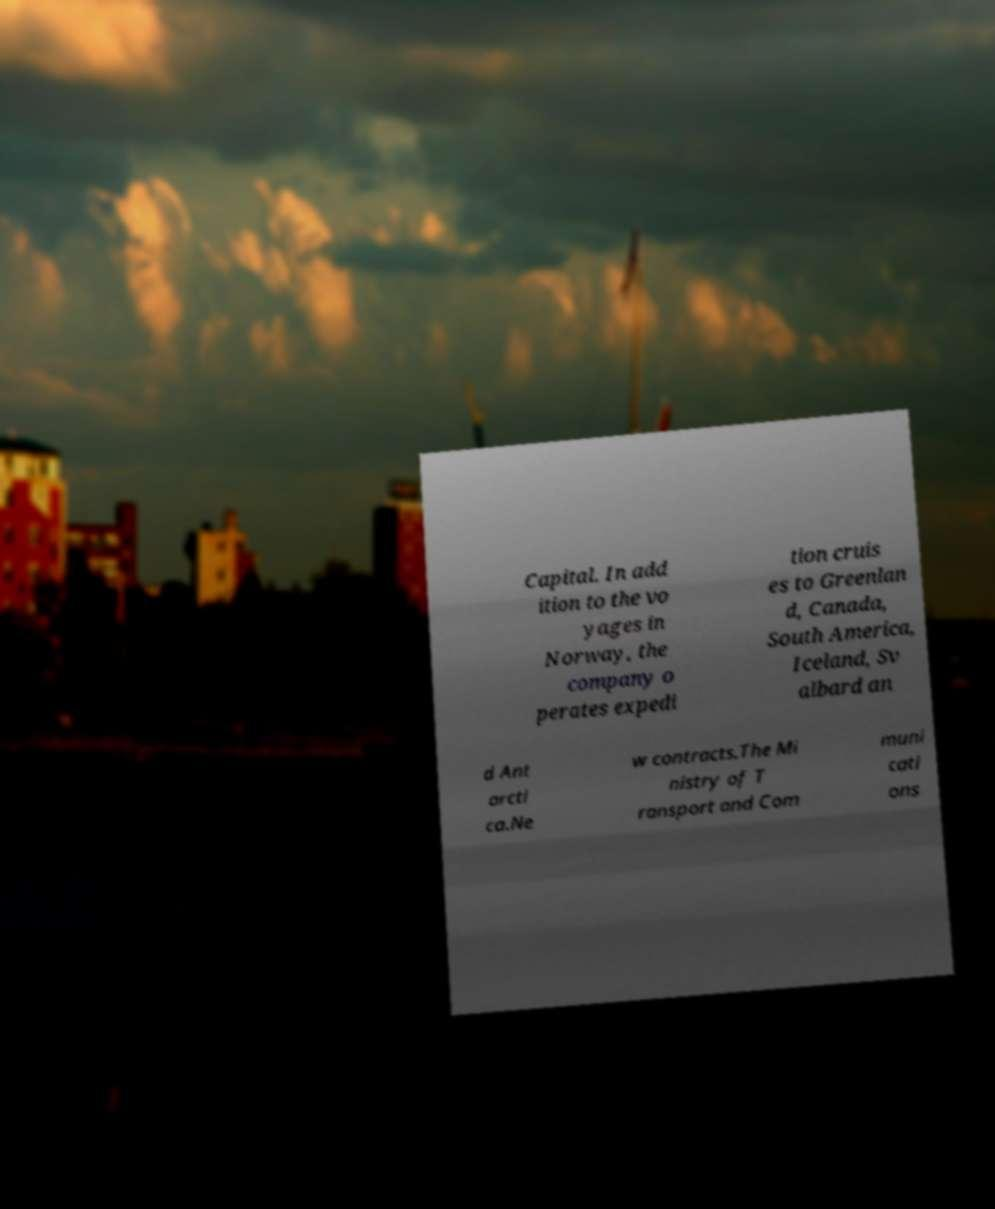Please read and relay the text visible in this image. What does it say? Capital. In add ition to the vo yages in Norway, the company o perates expedi tion cruis es to Greenlan d, Canada, South America, Iceland, Sv albard an d Ant arcti ca.Ne w contracts.The Mi nistry of T ransport and Com muni cati ons 